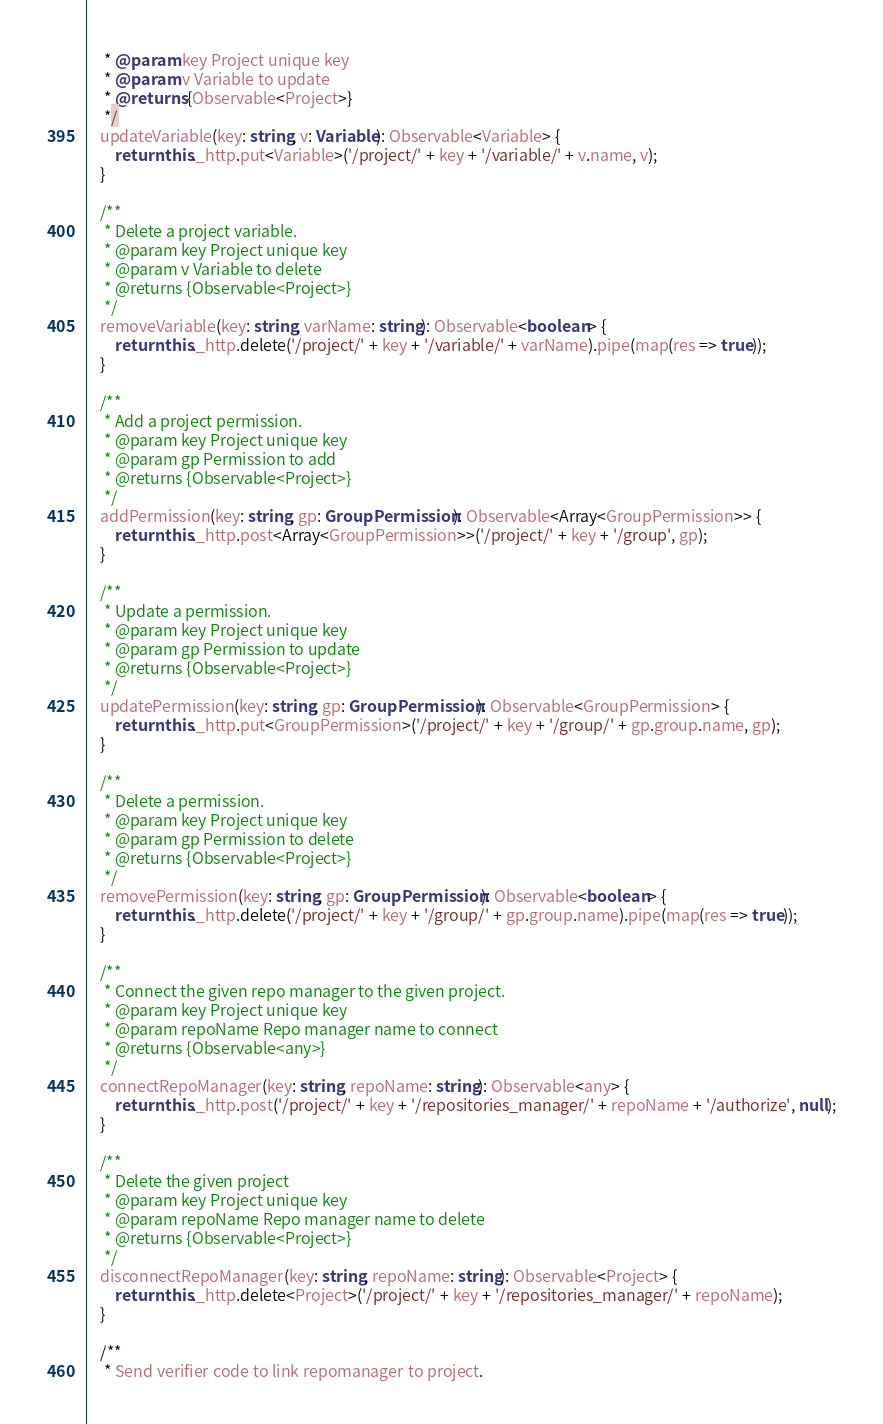<code> <loc_0><loc_0><loc_500><loc_500><_TypeScript_>     * @param key Project unique key
     * @param v Variable to update
     * @returns {Observable<Project>}
     */
    updateVariable(key: string, v: Variable): Observable<Variable> {
        return this._http.put<Variable>('/project/' + key + '/variable/' + v.name, v);
    }

    /**
     * Delete a project variable.
     * @param key Project unique key
     * @param v Variable to delete
     * @returns {Observable<Project>}
     */
    removeVariable(key: string, varName: string): Observable<boolean> {
        return this._http.delete('/project/' + key + '/variable/' + varName).pipe(map(res => true));
    }

    /**
     * Add a project permission.
     * @param key Project unique key
     * @param gp Permission to add
     * @returns {Observable<Project>}
     */
    addPermission(key: string, gp: GroupPermission): Observable<Array<GroupPermission>> {
        return this._http.post<Array<GroupPermission>>('/project/' + key + '/group', gp);
    }

    /**
     * Update a permission.
     * @param key Project unique key
     * @param gp Permission to update
     * @returns {Observable<Project>}
     */
    updatePermission(key: string, gp: GroupPermission): Observable<GroupPermission> {
        return this._http.put<GroupPermission>('/project/' + key + '/group/' + gp.group.name, gp);
    }

    /**
     * Delete a permission.
     * @param key Project unique key
     * @param gp Permission to delete
     * @returns {Observable<Project>}
     */
    removePermission(key: string, gp: GroupPermission): Observable<boolean> {
        return this._http.delete('/project/' + key + '/group/' + gp.group.name).pipe(map(res => true));
    }

    /**
     * Connect the given repo manager to the given project.
     * @param key Project unique key
     * @param repoName Repo manager name to connect
     * @returns {Observable<any>}
     */
    connectRepoManager(key: string, repoName: string): Observable<any> {
        return this._http.post('/project/' + key + '/repositories_manager/' + repoName + '/authorize', null);
    }

    /**
     * Delete the given project
     * @param key Project unique key
     * @param repoName Repo manager name to delete
     * @returns {Observable<Project>}
     */
    disconnectRepoManager(key: string, repoName: string): Observable<Project> {
        return this._http.delete<Project>('/project/' + key + '/repositories_manager/' + repoName);
    }

    /**
     * Send verifier code to link repomanager to project.</code> 